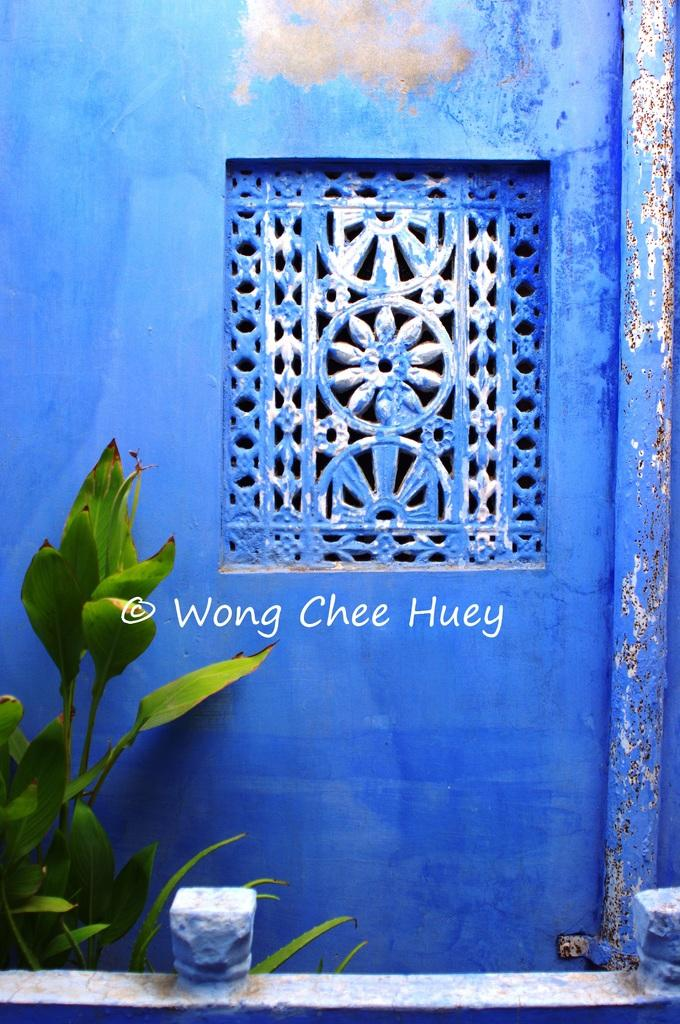What type of living organisms can be seen in the image? Plants can be seen in the image. What is visible in the background of the image? There is a wall in the image. What object can be seen in the image that is typically used for transporting fluids? There is a pipe in the image. What type of artwork is present in the image? There is a stone carving in the image. How many boys are depicted in the stone carving in the image? There are no boys present in the image, nor is there any indication of a stone carving depicting boys. 